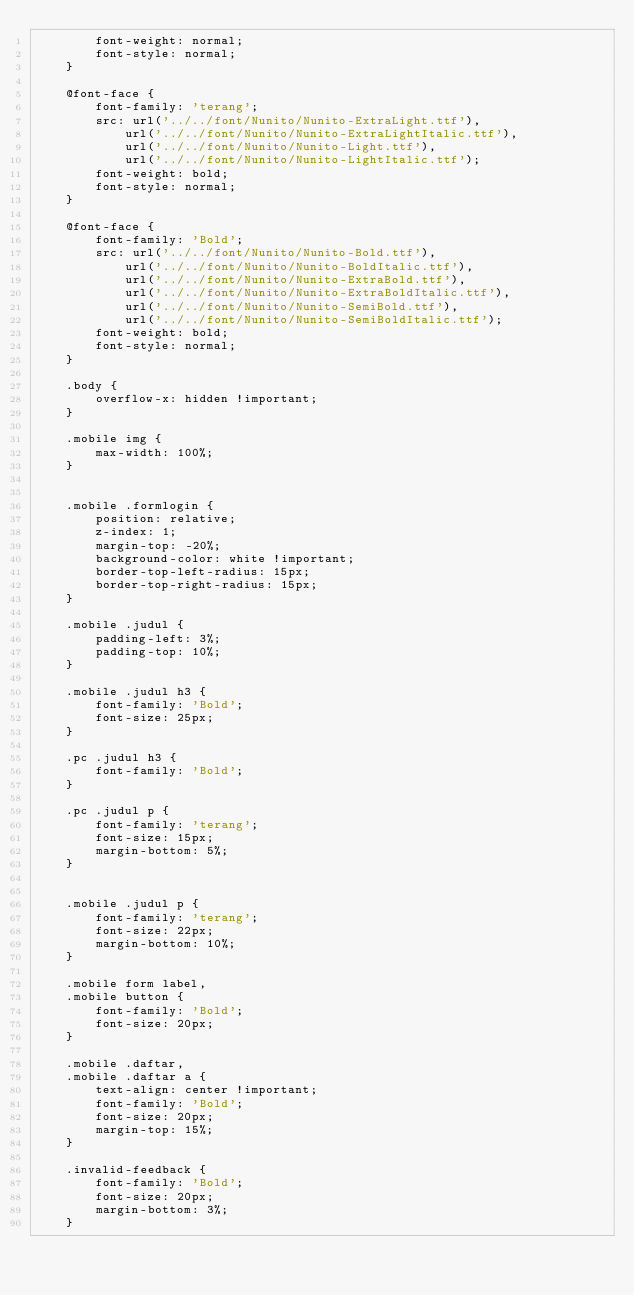<code> <loc_0><loc_0><loc_500><loc_500><_CSS_>        font-weight: normal;
        font-style: normal;
    }

    @font-face {
        font-family: 'terang';
        src: url('../../font/Nunito/Nunito-ExtraLight.ttf'),
            url('../../font/Nunito/Nunito-ExtraLightItalic.ttf'),
            url('../../font/Nunito/Nunito-Light.ttf'),
            url('../../font/Nunito/Nunito-LightItalic.ttf');
        font-weight: bold;
        font-style: normal;
    }

    @font-face {
        font-family: 'Bold';
        src: url('../../font/Nunito/Nunito-Bold.ttf'),
            url('../../font/Nunito/Nunito-BoldItalic.ttf'),
            url('../../font/Nunito/Nunito-ExtraBold.ttf'),
            url('../../font/Nunito/Nunito-ExtraBoldItalic.ttf'),
            url('../../font/Nunito/Nunito-SemiBold.ttf'),
            url('../../font/Nunito/Nunito-SemiBoldItalic.ttf');
        font-weight: bold;
        font-style: normal;
    }

    .body {
        overflow-x: hidden !important;
    }

    .mobile img {
        max-width: 100%;
    }


    .mobile .formlogin {
        position: relative;
        z-index: 1;
        margin-top: -20%;
        background-color: white !important;
        border-top-left-radius: 15px;
        border-top-right-radius: 15px;
    }

    .mobile .judul {
        padding-left: 3%;
        padding-top: 10%;
    }

    .mobile .judul h3 {
        font-family: 'Bold';
        font-size: 25px;
    }

    .pc .judul h3 {
        font-family: 'Bold';
    }

    .pc .judul p {
        font-family: 'terang';
        font-size: 15px;
        margin-bottom: 5%;
    }


    .mobile .judul p {
        font-family: 'terang';
        font-size: 22px;
        margin-bottom: 10%;
    }

    .mobile form label,
    .mobile button {
        font-family: 'Bold';
        font-size: 20px;
    }

    .mobile .daftar,
    .mobile .daftar a {
        text-align: center !important;
        font-family: 'Bold';
        font-size: 20px;
        margin-top: 15%;
    }

    .invalid-feedback {
        font-family: 'Bold';
        font-size: 20px;
        margin-bottom: 3%;
    }</code> 